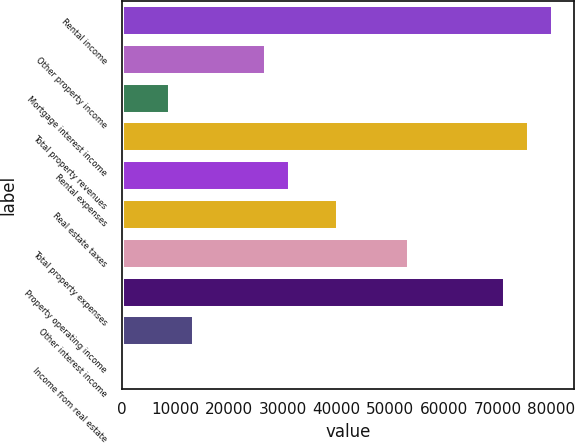<chart> <loc_0><loc_0><loc_500><loc_500><bar_chart><fcel>Rental income<fcel>Other property income<fcel>Mortgage interest income<fcel>Total property revenues<fcel>Rental expenses<fcel>Real estate taxes<fcel>Total property expenses<fcel>Property operating income<fcel>Other interest income<fcel>Income from real estate<nl><fcel>80245<fcel>26857<fcel>9061<fcel>75796<fcel>31306<fcel>40204<fcel>53551<fcel>71347<fcel>13510<fcel>163<nl></chart> 